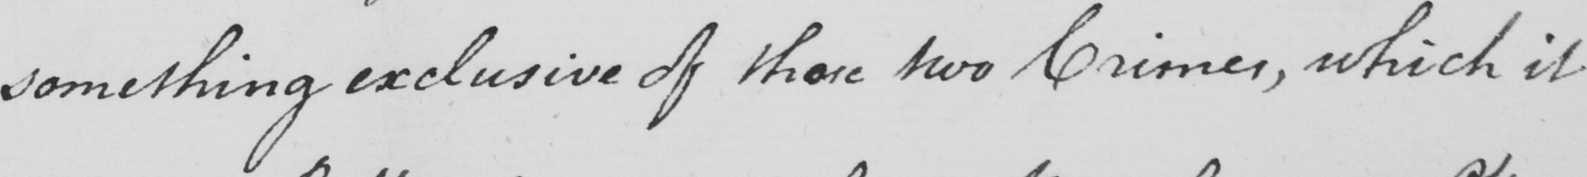Can you read and transcribe this handwriting? something exclusive of those two Crimes , which it 